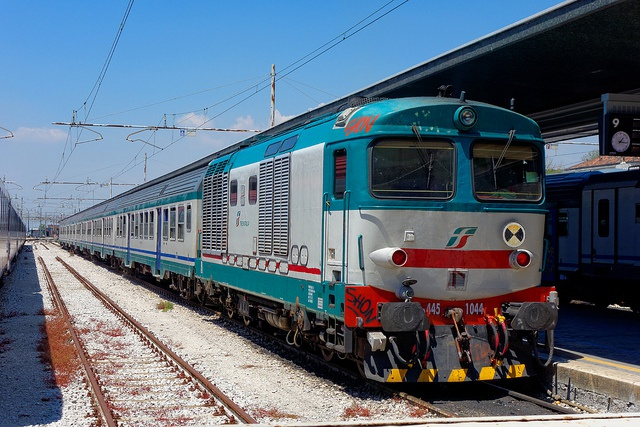Describe the objects in this image and their specific colors. I can see train in lightblue, black, gray, darkgray, and teal tones, train in lightblue, black, navy, darkgray, and gray tones, and clock in lightblue, gray, and black tones in this image. 